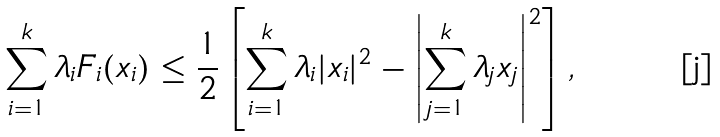Convert formula to latex. <formula><loc_0><loc_0><loc_500><loc_500>\sum _ { i = 1 } ^ { k } \lambda _ { i } F _ { i } ( x _ { i } ) \leq \frac { 1 } { 2 } \left [ \sum _ { i = 1 } ^ { k } \lambda _ { i } | x _ { i } | ^ { 2 } - \left | \sum _ { j = 1 } ^ { k } \lambda _ { j } x _ { j } \right | ^ { 2 } \right ] ,</formula> 